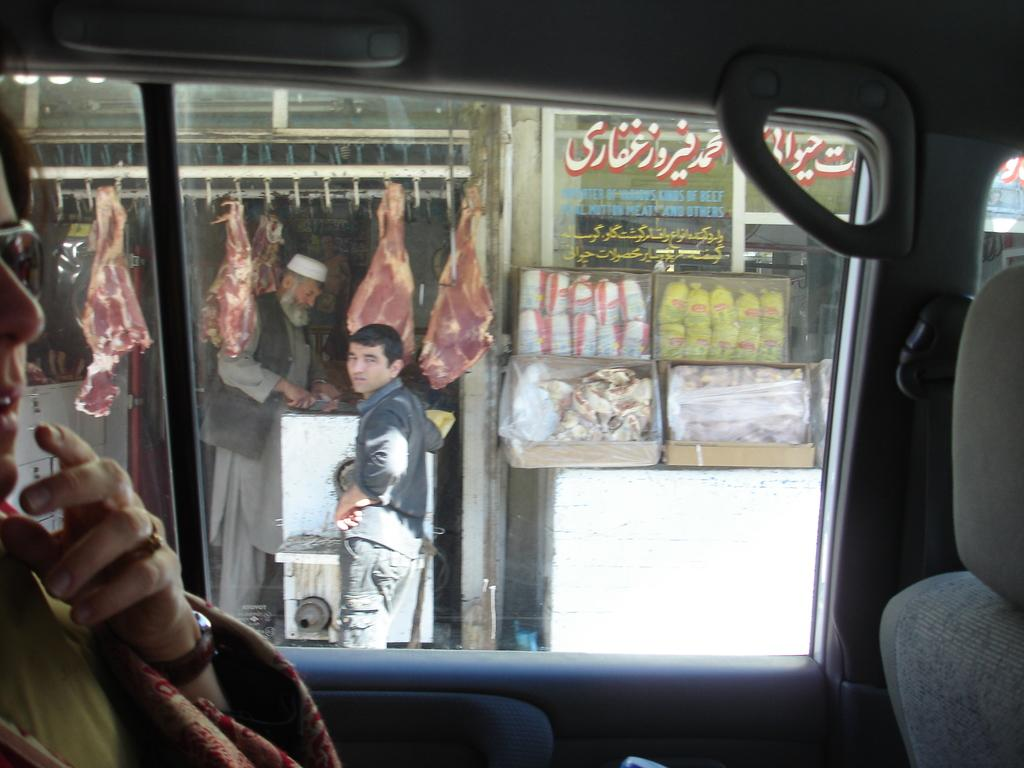What is the main subject of the image? There is a vehicle in the image. Who is inside the vehicle? A person is sitting in the vehicle. Are there any other people in the image? Yes, there are two persons standing outside the vehicle. What else can be seen in the image? There is meat visible in the image. What type of structure is in the background? There is a building in the image. What type of growth can be seen on the vehicle in the image? There is no visible growth on the vehicle in the image. Is there a hose attached to the building in the image? There is no hose visible in the image. 